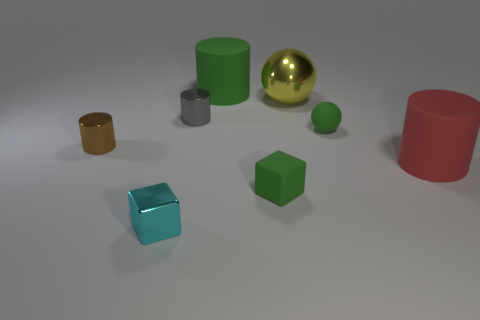Are there more tiny green rubber cylinders than large green cylinders?
Make the answer very short. No. What is the material of the red cylinder?
Provide a short and direct response. Rubber. Is the size of the sphere that is in front of the gray metal cylinder the same as the gray object?
Your answer should be compact. Yes. There is a matte cylinder that is on the left side of the green cube; what is its size?
Offer a very short reply. Large. How many large cylinders are there?
Give a very brief answer. 2. Do the metal ball and the small rubber cube have the same color?
Provide a short and direct response. No. The shiny thing that is both to the right of the shiny block and in front of the yellow object is what color?
Your response must be concise. Gray. There is a cyan block; are there any green matte cylinders on the right side of it?
Provide a short and direct response. Yes. There is a small cube behind the shiny cube; what number of red things are to the right of it?
Your response must be concise. 1. What size is the cyan object that is made of the same material as the yellow object?
Provide a short and direct response. Small. 